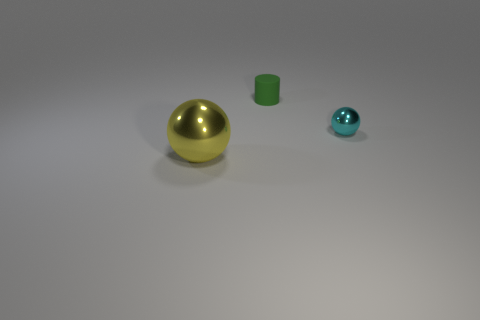How might these objects be used in a children's educational setting? In a children's educational setting, these objects could be excellent tools for a variety of learning activities. The distinct colors and shapes are great for teaching basic color recognition and geometry. Because they vary in size, they could also be used to help children understand concepts of size comparison, ordering by size, and counting. Moreover, the shiny surfaces might engage a child's curiosity about materials and light reflection, opening discussions about properties of different materials and how they interact with light. 